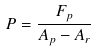Convert formula to latex. <formula><loc_0><loc_0><loc_500><loc_500>P = \frac { F _ { p } } { A _ { p } - A _ { r } }</formula> 